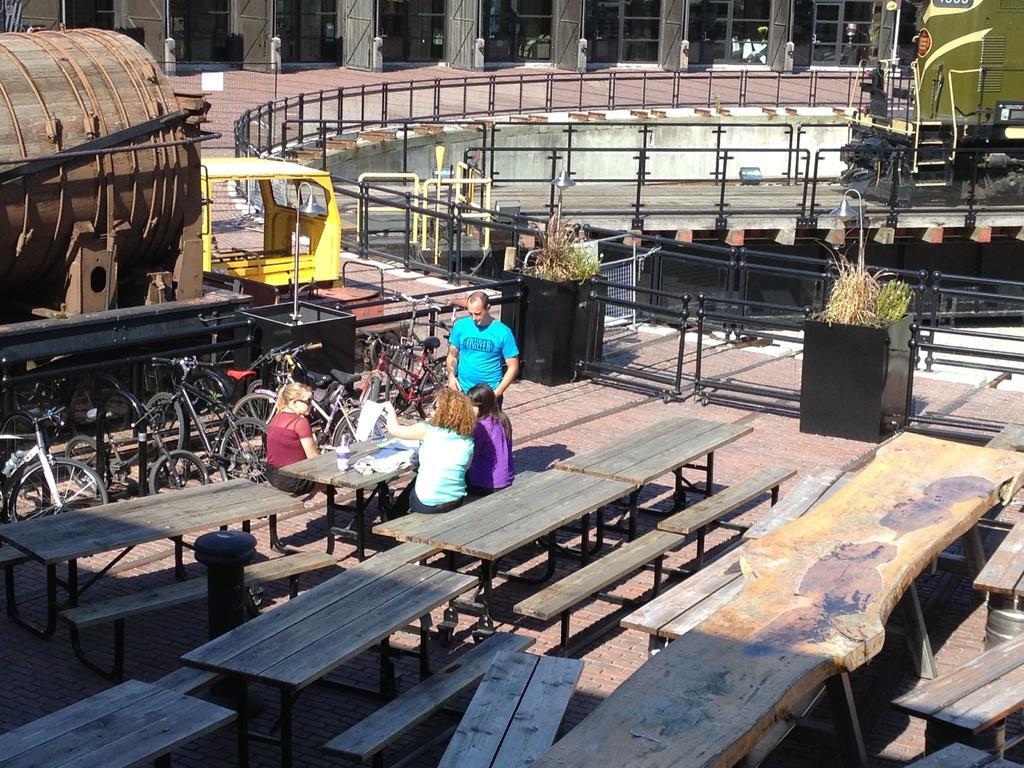Describe this image in one or two sentences. In this image there are four people, three people are sitting and one is standing. There is a bottle, cover on the table. There are bicycles behind the table. At the back there is a train and there is a building, there are some plants. 